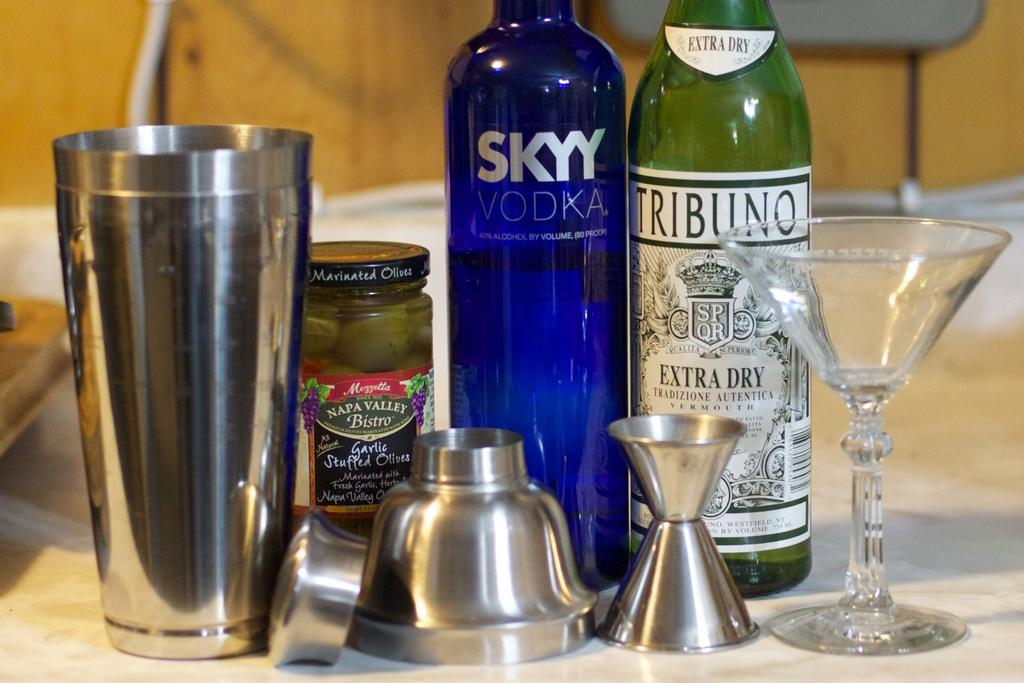What types of containers are visible in the image? There are bottles, glasses, and a jar in the image. What other object can be seen in the image? There is an antique in the image. Where are these objects located in the image? All of these objects are placed on a table. What type of veil can be seen covering the moon in the image? There is no veil or moon present in the image; it only features bottles, glasses, a jar, an antique, and a table. 